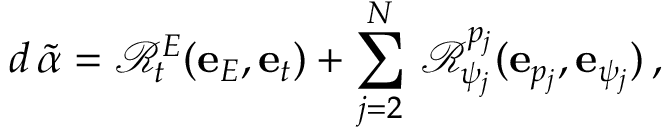Convert formula to latex. <formula><loc_0><loc_0><loc_500><loc_500>d \, \widetilde { \alpha } = \mathcal { R } _ { t } ^ { E } ( e _ { E } , e _ { t } ) + \sum _ { j = 2 } ^ { N } \, \mathcal { R } _ { \psi _ { j } } ^ { p _ { j } } ( e _ { p _ { j } } , e _ { \psi _ { j } } ) \, ,</formula> 